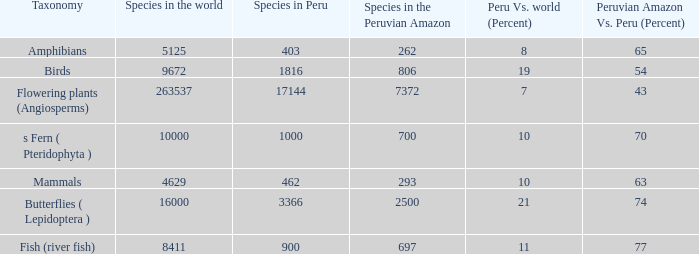What's the lowest count of species in the peruvian amazon with the classification of ferns (pteridophyta)? 700.0. 